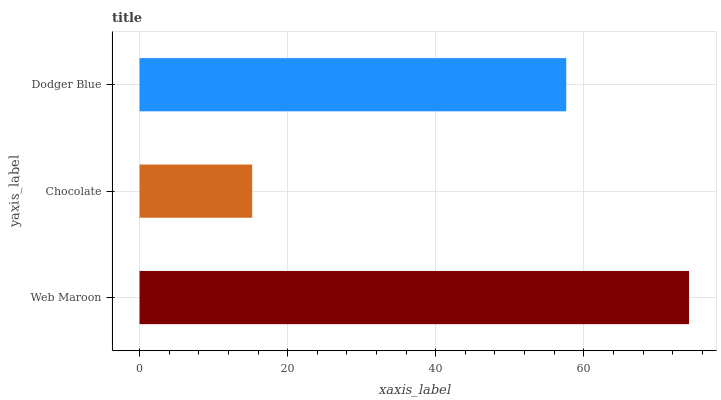Is Chocolate the minimum?
Answer yes or no. Yes. Is Web Maroon the maximum?
Answer yes or no. Yes. Is Dodger Blue the minimum?
Answer yes or no. No. Is Dodger Blue the maximum?
Answer yes or no. No. Is Dodger Blue greater than Chocolate?
Answer yes or no. Yes. Is Chocolate less than Dodger Blue?
Answer yes or no. Yes. Is Chocolate greater than Dodger Blue?
Answer yes or no. No. Is Dodger Blue less than Chocolate?
Answer yes or no. No. Is Dodger Blue the high median?
Answer yes or no. Yes. Is Dodger Blue the low median?
Answer yes or no. Yes. Is Chocolate the high median?
Answer yes or no. No. Is Chocolate the low median?
Answer yes or no. No. 